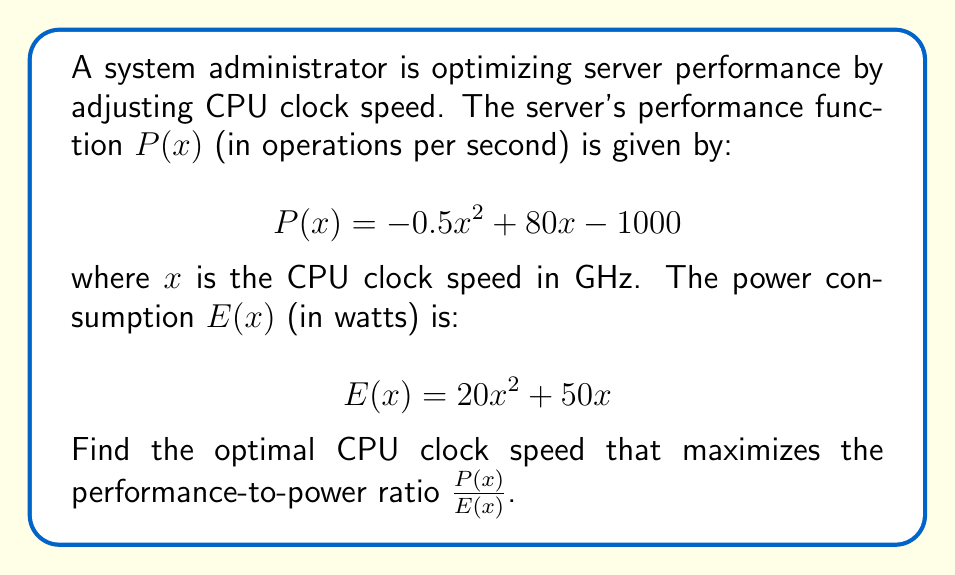Show me your answer to this math problem. To find the optimal CPU clock speed, we need to maximize the performance-to-power ratio. Let's define this ratio as $R(x)$:

$$R(x) = \frac{P(x)}{E(x)} = \frac{-0.5x^2 + 80x - 1000}{20x^2 + 50x}$$

To find the maximum, we need to find where the derivative of $R(x)$ equals zero:

1) First, let's calculate $R'(x)$ using the quotient rule:

   $$R'(x) = \frac{(-x+80)(20x^2+50x) - (-0.5x^2+80x-1000)(40x+50)}{(20x^2+50x)^2}$$

2) Simplify the numerator:

   $$R'(x) = \frac{-20x^3-50x^2+1600x^2+4000x+20x^3-1600x^2+2000x-40000}{(20x^2+50x)^2}$$

3) Combine like terms:

   $$R'(x) = \frac{-50x^2+6000x-40000}{(20x^2+50x)^2}$$

4) Set $R'(x) = 0$ and solve for $x$:

   $$-50x^2+6000x-40000 = 0$$

5) This is a quadratic equation. Solve using the quadratic formula:

   $$x = \frac{-b \pm \sqrt{b^2-4ac}}{2a}$$

   Where $a=-50$, $b=6000$, and $c=-40000$

6) Plugging in the values:

   $$x = \frac{-6000 \pm \sqrt{6000^2-4(-50)(-40000)}}{2(-50)}$$

7) Simplify:

   $$x = \frac{-6000 \pm \sqrt{36000000-8000000}}{-100} = \frac{-6000 \pm \sqrt{28000000}}{-100}$$

   $$x = \frac{-6000 \pm 5291.50}{-100} \approx 12.92 \text{ or } 6.09$$

8) The second solution (6.09) can be discarded as it results in a lower performance-to-power ratio.

Therefore, the optimal CPU clock speed is approximately 12.92 GHz.
Answer: 12.92 GHz 